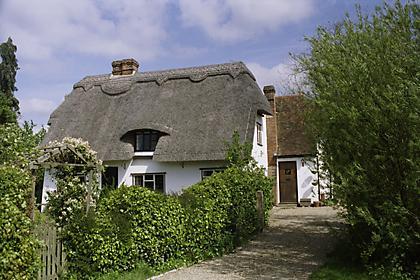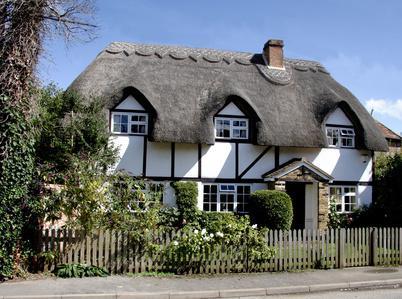The first image is the image on the left, the second image is the image on the right. For the images displayed, is the sentence "At least one of the 2 houses has a wooden fence around it." factually correct? Answer yes or no. Yes. The first image is the image on the left, the second image is the image on the right. Examine the images to the left and right. Is the description "One of the houses has two chimneys, one on each end of the roof line." accurate? Answer yes or no. No. 